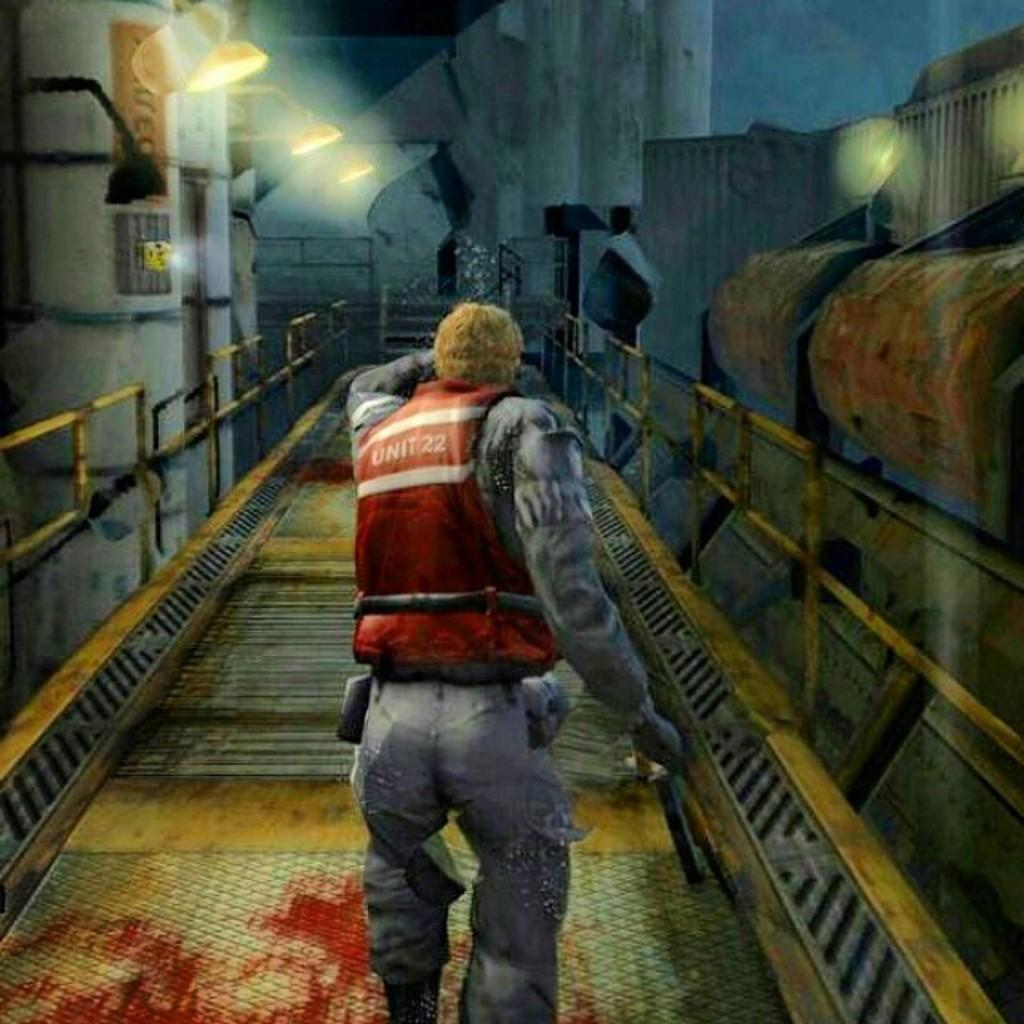What type of image is being described? The image is animated. What is the person in the image doing? There is a person walking in the image. What can be seen illuminating the scene in the image? There are lights in the image. What architectural features are present in the image? There are pillars in the image. How many boards are being used by the boys in the image? There are no boards or boys present in the image. 